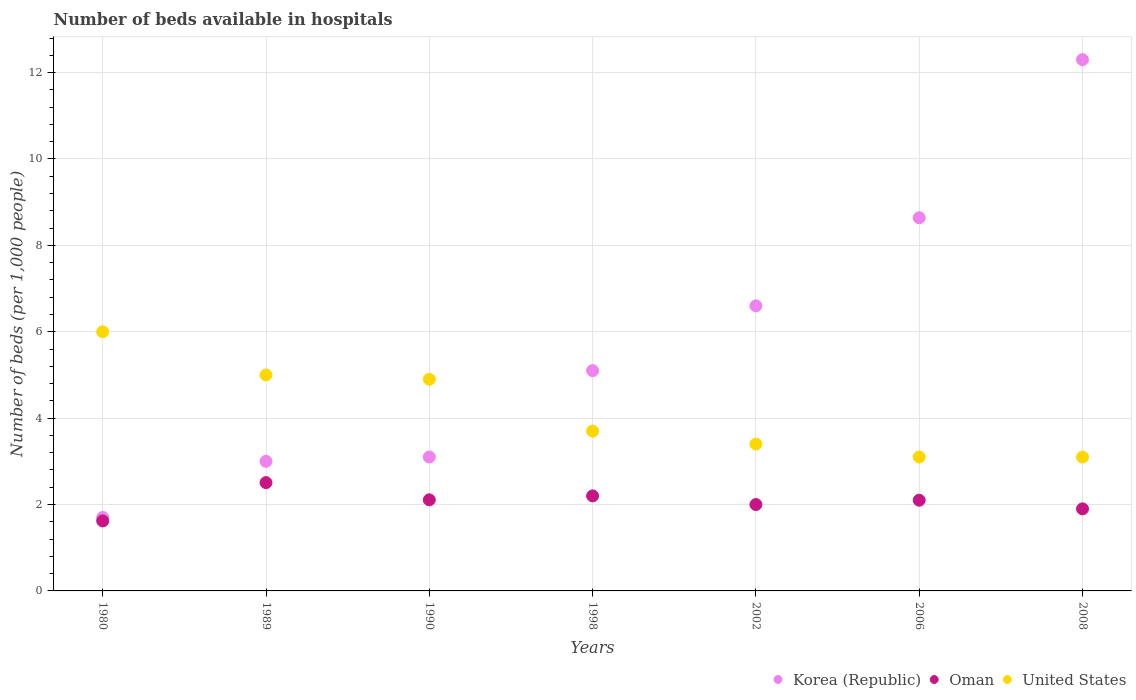How many different coloured dotlines are there?
Offer a very short reply. 3. Is the number of dotlines equal to the number of legend labels?
Offer a very short reply. Yes. What is the number of beds in the hospiatls of in Korea (Republic) in 1998?
Provide a short and direct response. 5.1. Across all years, what is the maximum number of beds in the hospiatls of in Oman?
Keep it short and to the point. 2.51. Across all years, what is the minimum number of beds in the hospiatls of in Korea (Republic)?
Offer a very short reply. 1.7. In which year was the number of beds in the hospiatls of in United States maximum?
Your answer should be compact. 1980. In which year was the number of beds in the hospiatls of in United States minimum?
Ensure brevity in your answer.  2006. What is the total number of beds in the hospiatls of in Korea (Republic) in the graph?
Provide a succinct answer. 40.44. What is the difference between the number of beds in the hospiatls of in United States in 1990 and that in 2008?
Your response must be concise. 1.8. What is the difference between the number of beds in the hospiatls of in Korea (Republic) in 2006 and the number of beds in the hospiatls of in Oman in 2008?
Offer a terse response. 6.74. What is the average number of beds in the hospiatls of in Oman per year?
Ensure brevity in your answer.  2.06. In the year 2008, what is the difference between the number of beds in the hospiatls of in Korea (Republic) and number of beds in the hospiatls of in United States?
Give a very brief answer. 9.2. What is the ratio of the number of beds in the hospiatls of in Oman in 1998 to that in 2008?
Offer a very short reply. 1.16. Is the number of beds in the hospiatls of in Korea (Republic) in 1989 less than that in 2006?
Ensure brevity in your answer.  Yes. What is the difference between the highest and the second highest number of beds in the hospiatls of in Korea (Republic)?
Your response must be concise. 3.66. In how many years, is the number of beds in the hospiatls of in Oman greater than the average number of beds in the hospiatls of in Oman taken over all years?
Your answer should be compact. 4. Is the sum of the number of beds in the hospiatls of in Oman in 1998 and 2006 greater than the maximum number of beds in the hospiatls of in Korea (Republic) across all years?
Make the answer very short. No. Is the number of beds in the hospiatls of in Korea (Republic) strictly greater than the number of beds in the hospiatls of in United States over the years?
Your response must be concise. No. Is the number of beds in the hospiatls of in Korea (Republic) strictly less than the number of beds in the hospiatls of in Oman over the years?
Your answer should be very brief. No. How many years are there in the graph?
Provide a succinct answer. 7. Are the values on the major ticks of Y-axis written in scientific E-notation?
Ensure brevity in your answer.  No. Does the graph contain grids?
Your answer should be very brief. Yes. Where does the legend appear in the graph?
Provide a succinct answer. Bottom right. How are the legend labels stacked?
Make the answer very short. Horizontal. What is the title of the graph?
Your response must be concise. Number of beds available in hospitals. Does "French Polynesia" appear as one of the legend labels in the graph?
Offer a very short reply. No. What is the label or title of the Y-axis?
Provide a succinct answer. Number of beds (per 1,0 people). What is the Number of beds (per 1,000 people) in Korea (Republic) in 1980?
Your answer should be very brief. 1.7. What is the Number of beds (per 1,000 people) of Oman in 1980?
Provide a succinct answer. 1.62. What is the Number of beds (per 1,000 people) of United States in 1980?
Offer a terse response. 6. What is the Number of beds (per 1,000 people) in Oman in 1989?
Keep it short and to the point. 2.51. What is the Number of beds (per 1,000 people) of Korea (Republic) in 1990?
Provide a succinct answer. 3.1. What is the Number of beds (per 1,000 people) in Oman in 1990?
Provide a succinct answer. 2.11. What is the Number of beds (per 1,000 people) of United States in 1990?
Offer a very short reply. 4.9. What is the Number of beds (per 1,000 people) of Korea (Republic) in 1998?
Your answer should be very brief. 5.1. What is the Number of beds (per 1,000 people) in Oman in 1998?
Keep it short and to the point. 2.2. What is the Number of beds (per 1,000 people) in United States in 1998?
Your answer should be very brief. 3.7. What is the Number of beds (per 1,000 people) in Korea (Republic) in 2002?
Your answer should be very brief. 6.6. What is the Number of beds (per 1,000 people) of Oman in 2002?
Keep it short and to the point. 2. What is the Number of beds (per 1,000 people) in United States in 2002?
Keep it short and to the point. 3.4. What is the Number of beds (per 1,000 people) of Korea (Republic) in 2006?
Offer a very short reply. 8.64. What is the Number of beds (per 1,000 people) of Oman in 2006?
Your response must be concise. 2.1. What is the Number of beds (per 1,000 people) of United States in 2006?
Offer a very short reply. 3.1. What is the Number of beds (per 1,000 people) of Korea (Republic) in 2008?
Provide a short and direct response. 12.3. What is the Number of beds (per 1,000 people) in United States in 2008?
Provide a short and direct response. 3.1. Across all years, what is the maximum Number of beds (per 1,000 people) of Oman?
Your response must be concise. 2.51. Across all years, what is the minimum Number of beds (per 1,000 people) in Korea (Republic)?
Your answer should be very brief. 1.7. Across all years, what is the minimum Number of beds (per 1,000 people) of Oman?
Give a very brief answer. 1.62. Across all years, what is the minimum Number of beds (per 1,000 people) of United States?
Your answer should be very brief. 3.1. What is the total Number of beds (per 1,000 people) in Korea (Republic) in the graph?
Ensure brevity in your answer.  40.44. What is the total Number of beds (per 1,000 people) of Oman in the graph?
Give a very brief answer. 14.44. What is the total Number of beds (per 1,000 people) in United States in the graph?
Provide a short and direct response. 29.2. What is the difference between the Number of beds (per 1,000 people) of Oman in 1980 and that in 1989?
Offer a terse response. -0.89. What is the difference between the Number of beds (per 1,000 people) of Korea (Republic) in 1980 and that in 1990?
Offer a terse response. -1.4. What is the difference between the Number of beds (per 1,000 people) in Oman in 1980 and that in 1990?
Your response must be concise. -0.49. What is the difference between the Number of beds (per 1,000 people) in United States in 1980 and that in 1990?
Give a very brief answer. 1.1. What is the difference between the Number of beds (per 1,000 people) in Oman in 1980 and that in 1998?
Make the answer very short. -0.58. What is the difference between the Number of beds (per 1,000 people) of Oman in 1980 and that in 2002?
Keep it short and to the point. -0.38. What is the difference between the Number of beds (per 1,000 people) in Korea (Republic) in 1980 and that in 2006?
Provide a succinct answer. -6.94. What is the difference between the Number of beds (per 1,000 people) of Oman in 1980 and that in 2006?
Offer a very short reply. -0.48. What is the difference between the Number of beds (per 1,000 people) in Korea (Republic) in 1980 and that in 2008?
Provide a short and direct response. -10.6. What is the difference between the Number of beds (per 1,000 people) in Oman in 1980 and that in 2008?
Make the answer very short. -0.28. What is the difference between the Number of beds (per 1,000 people) in United States in 1980 and that in 2008?
Provide a short and direct response. 2.9. What is the difference between the Number of beds (per 1,000 people) in Oman in 1989 and that in 1990?
Your response must be concise. 0.4. What is the difference between the Number of beds (per 1,000 people) of United States in 1989 and that in 1990?
Offer a terse response. 0.1. What is the difference between the Number of beds (per 1,000 people) of Oman in 1989 and that in 1998?
Provide a short and direct response. 0.31. What is the difference between the Number of beds (per 1,000 people) in United States in 1989 and that in 1998?
Provide a short and direct response. 1.3. What is the difference between the Number of beds (per 1,000 people) of Korea (Republic) in 1989 and that in 2002?
Ensure brevity in your answer.  -3.6. What is the difference between the Number of beds (per 1,000 people) in Oman in 1989 and that in 2002?
Your response must be concise. 0.51. What is the difference between the Number of beds (per 1,000 people) in Korea (Republic) in 1989 and that in 2006?
Your response must be concise. -5.64. What is the difference between the Number of beds (per 1,000 people) in Oman in 1989 and that in 2006?
Offer a very short reply. 0.41. What is the difference between the Number of beds (per 1,000 people) of United States in 1989 and that in 2006?
Keep it short and to the point. 1.9. What is the difference between the Number of beds (per 1,000 people) in Oman in 1989 and that in 2008?
Your response must be concise. 0.61. What is the difference between the Number of beds (per 1,000 people) of United States in 1989 and that in 2008?
Offer a terse response. 1.9. What is the difference between the Number of beds (per 1,000 people) in Korea (Republic) in 1990 and that in 1998?
Make the answer very short. -2. What is the difference between the Number of beds (per 1,000 people) of Oman in 1990 and that in 1998?
Make the answer very short. -0.09. What is the difference between the Number of beds (per 1,000 people) of Oman in 1990 and that in 2002?
Make the answer very short. 0.11. What is the difference between the Number of beds (per 1,000 people) in United States in 1990 and that in 2002?
Your response must be concise. 1.5. What is the difference between the Number of beds (per 1,000 people) of Korea (Republic) in 1990 and that in 2006?
Provide a short and direct response. -5.54. What is the difference between the Number of beds (per 1,000 people) in Oman in 1990 and that in 2006?
Make the answer very short. 0.01. What is the difference between the Number of beds (per 1,000 people) of Korea (Republic) in 1990 and that in 2008?
Offer a very short reply. -9.2. What is the difference between the Number of beds (per 1,000 people) of Oman in 1990 and that in 2008?
Provide a short and direct response. 0.21. What is the difference between the Number of beds (per 1,000 people) in United States in 1990 and that in 2008?
Give a very brief answer. 1.8. What is the difference between the Number of beds (per 1,000 people) in United States in 1998 and that in 2002?
Offer a very short reply. 0.3. What is the difference between the Number of beds (per 1,000 people) in Korea (Republic) in 1998 and that in 2006?
Give a very brief answer. -3.54. What is the difference between the Number of beds (per 1,000 people) in Oman in 1998 and that in 2006?
Ensure brevity in your answer.  0.1. What is the difference between the Number of beds (per 1,000 people) in Korea (Republic) in 1998 and that in 2008?
Keep it short and to the point. -7.2. What is the difference between the Number of beds (per 1,000 people) in United States in 1998 and that in 2008?
Offer a very short reply. 0.6. What is the difference between the Number of beds (per 1,000 people) of Korea (Republic) in 2002 and that in 2006?
Your response must be concise. -2.04. What is the difference between the Number of beds (per 1,000 people) in United States in 2002 and that in 2006?
Provide a succinct answer. 0.3. What is the difference between the Number of beds (per 1,000 people) in United States in 2002 and that in 2008?
Your response must be concise. 0.3. What is the difference between the Number of beds (per 1,000 people) of Korea (Republic) in 2006 and that in 2008?
Offer a very short reply. -3.66. What is the difference between the Number of beds (per 1,000 people) of Korea (Republic) in 1980 and the Number of beds (per 1,000 people) of Oman in 1989?
Keep it short and to the point. -0.81. What is the difference between the Number of beds (per 1,000 people) of Oman in 1980 and the Number of beds (per 1,000 people) of United States in 1989?
Make the answer very short. -3.38. What is the difference between the Number of beds (per 1,000 people) in Korea (Republic) in 1980 and the Number of beds (per 1,000 people) in Oman in 1990?
Make the answer very short. -0.41. What is the difference between the Number of beds (per 1,000 people) of Korea (Republic) in 1980 and the Number of beds (per 1,000 people) of United States in 1990?
Offer a very short reply. -3.2. What is the difference between the Number of beds (per 1,000 people) in Oman in 1980 and the Number of beds (per 1,000 people) in United States in 1990?
Provide a succinct answer. -3.28. What is the difference between the Number of beds (per 1,000 people) of Korea (Republic) in 1980 and the Number of beds (per 1,000 people) of United States in 1998?
Provide a short and direct response. -2. What is the difference between the Number of beds (per 1,000 people) in Oman in 1980 and the Number of beds (per 1,000 people) in United States in 1998?
Your answer should be very brief. -2.08. What is the difference between the Number of beds (per 1,000 people) of Korea (Republic) in 1980 and the Number of beds (per 1,000 people) of Oman in 2002?
Keep it short and to the point. -0.3. What is the difference between the Number of beds (per 1,000 people) of Korea (Republic) in 1980 and the Number of beds (per 1,000 people) of United States in 2002?
Your answer should be very brief. -1.7. What is the difference between the Number of beds (per 1,000 people) of Oman in 1980 and the Number of beds (per 1,000 people) of United States in 2002?
Give a very brief answer. -1.78. What is the difference between the Number of beds (per 1,000 people) in Oman in 1980 and the Number of beds (per 1,000 people) in United States in 2006?
Your answer should be very brief. -1.48. What is the difference between the Number of beds (per 1,000 people) of Oman in 1980 and the Number of beds (per 1,000 people) of United States in 2008?
Make the answer very short. -1.48. What is the difference between the Number of beds (per 1,000 people) of Korea (Republic) in 1989 and the Number of beds (per 1,000 people) of Oman in 1990?
Your answer should be very brief. 0.89. What is the difference between the Number of beds (per 1,000 people) of Korea (Republic) in 1989 and the Number of beds (per 1,000 people) of United States in 1990?
Offer a very short reply. -1.9. What is the difference between the Number of beds (per 1,000 people) in Oman in 1989 and the Number of beds (per 1,000 people) in United States in 1990?
Offer a very short reply. -2.39. What is the difference between the Number of beds (per 1,000 people) in Korea (Republic) in 1989 and the Number of beds (per 1,000 people) in Oman in 1998?
Ensure brevity in your answer.  0.8. What is the difference between the Number of beds (per 1,000 people) in Korea (Republic) in 1989 and the Number of beds (per 1,000 people) in United States in 1998?
Your answer should be very brief. -0.7. What is the difference between the Number of beds (per 1,000 people) of Oman in 1989 and the Number of beds (per 1,000 people) of United States in 1998?
Offer a terse response. -1.19. What is the difference between the Number of beds (per 1,000 people) in Korea (Republic) in 1989 and the Number of beds (per 1,000 people) in United States in 2002?
Offer a terse response. -0.4. What is the difference between the Number of beds (per 1,000 people) of Oman in 1989 and the Number of beds (per 1,000 people) of United States in 2002?
Keep it short and to the point. -0.89. What is the difference between the Number of beds (per 1,000 people) in Korea (Republic) in 1989 and the Number of beds (per 1,000 people) in Oman in 2006?
Make the answer very short. 0.9. What is the difference between the Number of beds (per 1,000 people) in Oman in 1989 and the Number of beds (per 1,000 people) in United States in 2006?
Provide a short and direct response. -0.59. What is the difference between the Number of beds (per 1,000 people) of Korea (Republic) in 1989 and the Number of beds (per 1,000 people) of Oman in 2008?
Ensure brevity in your answer.  1.1. What is the difference between the Number of beds (per 1,000 people) in Korea (Republic) in 1989 and the Number of beds (per 1,000 people) in United States in 2008?
Offer a very short reply. -0.1. What is the difference between the Number of beds (per 1,000 people) of Oman in 1989 and the Number of beds (per 1,000 people) of United States in 2008?
Provide a short and direct response. -0.59. What is the difference between the Number of beds (per 1,000 people) in Korea (Republic) in 1990 and the Number of beds (per 1,000 people) in Oman in 1998?
Your answer should be compact. 0.9. What is the difference between the Number of beds (per 1,000 people) of Korea (Republic) in 1990 and the Number of beds (per 1,000 people) of United States in 1998?
Ensure brevity in your answer.  -0.6. What is the difference between the Number of beds (per 1,000 people) of Oman in 1990 and the Number of beds (per 1,000 people) of United States in 1998?
Offer a terse response. -1.59. What is the difference between the Number of beds (per 1,000 people) of Oman in 1990 and the Number of beds (per 1,000 people) of United States in 2002?
Ensure brevity in your answer.  -1.29. What is the difference between the Number of beds (per 1,000 people) in Korea (Republic) in 1990 and the Number of beds (per 1,000 people) in Oman in 2006?
Make the answer very short. 1. What is the difference between the Number of beds (per 1,000 people) in Korea (Republic) in 1990 and the Number of beds (per 1,000 people) in United States in 2006?
Your response must be concise. -0. What is the difference between the Number of beds (per 1,000 people) in Oman in 1990 and the Number of beds (per 1,000 people) in United States in 2006?
Offer a very short reply. -0.99. What is the difference between the Number of beds (per 1,000 people) of Oman in 1990 and the Number of beds (per 1,000 people) of United States in 2008?
Keep it short and to the point. -0.99. What is the difference between the Number of beds (per 1,000 people) of Korea (Republic) in 1998 and the Number of beds (per 1,000 people) of Oman in 2006?
Offer a very short reply. 3. What is the difference between the Number of beds (per 1,000 people) in Korea (Republic) in 1998 and the Number of beds (per 1,000 people) in United States in 2006?
Keep it short and to the point. 2. What is the difference between the Number of beds (per 1,000 people) in Oman in 1998 and the Number of beds (per 1,000 people) in United States in 2008?
Keep it short and to the point. -0.9. What is the difference between the Number of beds (per 1,000 people) in Korea (Republic) in 2002 and the Number of beds (per 1,000 people) in Oman in 2006?
Give a very brief answer. 4.5. What is the difference between the Number of beds (per 1,000 people) of Korea (Republic) in 2002 and the Number of beds (per 1,000 people) of United States in 2006?
Your answer should be compact. 3.5. What is the difference between the Number of beds (per 1,000 people) in Korea (Republic) in 2002 and the Number of beds (per 1,000 people) in Oman in 2008?
Offer a very short reply. 4.7. What is the difference between the Number of beds (per 1,000 people) in Korea (Republic) in 2002 and the Number of beds (per 1,000 people) in United States in 2008?
Your response must be concise. 3.5. What is the difference between the Number of beds (per 1,000 people) of Oman in 2002 and the Number of beds (per 1,000 people) of United States in 2008?
Offer a very short reply. -1.1. What is the difference between the Number of beds (per 1,000 people) of Korea (Republic) in 2006 and the Number of beds (per 1,000 people) of Oman in 2008?
Provide a succinct answer. 6.74. What is the difference between the Number of beds (per 1,000 people) in Korea (Republic) in 2006 and the Number of beds (per 1,000 people) in United States in 2008?
Ensure brevity in your answer.  5.54. What is the difference between the Number of beds (per 1,000 people) in Oman in 2006 and the Number of beds (per 1,000 people) in United States in 2008?
Keep it short and to the point. -1. What is the average Number of beds (per 1,000 people) in Korea (Republic) per year?
Your response must be concise. 5.78. What is the average Number of beds (per 1,000 people) of Oman per year?
Give a very brief answer. 2.06. What is the average Number of beds (per 1,000 people) in United States per year?
Provide a short and direct response. 4.17. In the year 1980, what is the difference between the Number of beds (per 1,000 people) of Korea (Republic) and Number of beds (per 1,000 people) of Oman?
Offer a terse response. 0.08. In the year 1980, what is the difference between the Number of beds (per 1,000 people) in Oman and Number of beds (per 1,000 people) in United States?
Provide a succinct answer. -4.38. In the year 1989, what is the difference between the Number of beds (per 1,000 people) in Korea (Republic) and Number of beds (per 1,000 people) in Oman?
Provide a short and direct response. 0.49. In the year 1989, what is the difference between the Number of beds (per 1,000 people) of Korea (Republic) and Number of beds (per 1,000 people) of United States?
Provide a short and direct response. -2. In the year 1989, what is the difference between the Number of beds (per 1,000 people) in Oman and Number of beds (per 1,000 people) in United States?
Ensure brevity in your answer.  -2.49. In the year 1990, what is the difference between the Number of beds (per 1,000 people) in Korea (Republic) and Number of beds (per 1,000 people) in Oman?
Ensure brevity in your answer.  0.99. In the year 1990, what is the difference between the Number of beds (per 1,000 people) of Oman and Number of beds (per 1,000 people) of United States?
Provide a succinct answer. -2.79. In the year 1998, what is the difference between the Number of beds (per 1,000 people) of Korea (Republic) and Number of beds (per 1,000 people) of Oman?
Offer a very short reply. 2.9. In the year 1998, what is the difference between the Number of beds (per 1,000 people) in Korea (Republic) and Number of beds (per 1,000 people) in United States?
Offer a very short reply. 1.4. In the year 1998, what is the difference between the Number of beds (per 1,000 people) in Oman and Number of beds (per 1,000 people) in United States?
Make the answer very short. -1.5. In the year 2002, what is the difference between the Number of beds (per 1,000 people) in Korea (Republic) and Number of beds (per 1,000 people) in United States?
Your response must be concise. 3.2. In the year 2002, what is the difference between the Number of beds (per 1,000 people) of Oman and Number of beds (per 1,000 people) of United States?
Offer a terse response. -1.4. In the year 2006, what is the difference between the Number of beds (per 1,000 people) of Korea (Republic) and Number of beds (per 1,000 people) of Oman?
Make the answer very short. 6.54. In the year 2006, what is the difference between the Number of beds (per 1,000 people) in Korea (Republic) and Number of beds (per 1,000 people) in United States?
Make the answer very short. 5.54. In the year 2008, what is the difference between the Number of beds (per 1,000 people) of Oman and Number of beds (per 1,000 people) of United States?
Offer a very short reply. -1.2. What is the ratio of the Number of beds (per 1,000 people) in Korea (Republic) in 1980 to that in 1989?
Provide a short and direct response. 0.57. What is the ratio of the Number of beds (per 1,000 people) of Oman in 1980 to that in 1989?
Your response must be concise. 0.65. What is the ratio of the Number of beds (per 1,000 people) of United States in 1980 to that in 1989?
Your answer should be compact. 1.2. What is the ratio of the Number of beds (per 1,000 people) of Korea (Republic) in 1980 to that in 1990?
Keep it short and to the point. 0.55. What is the ratio of the Number of beds (per 1,000 people) of Oman in 1980 to that in 1990?
Your answer should be very brief. 0.77. What is the ratio of the Number of beds (per 1,000 people) in United States in 1980 to that in 1990?
Offer a very short reply. 1.22. What is the ratio of the Number of beds (per 1,000 people) in Korea (Republic) in 1980 to that in 1998?
Keep it short and to the point. 0.33. What is the ratio of the Number of beds (per 1,000 people) of Oman in 1980 to that in 1998?
Offer a very short reply. 0.74. What is the ratio of the Number of beds (per 1,000 people) of United States in 1980 to that in 1998?
Your response must be concise. 1.62. What is the ratio of the Number of beds (per 1,000 people) in Korea (Republic) in 1980 to that in 2002?
Offer a terse response. 0.26. What is the ratio of the Number of beds (per 1,000 people) of Oman in 1980 to that in 2002?
Ensure brevity in your answer.  0.81. What is the ratio of the Number of beds (per 1,000 people) of United States in 1980 to that in 2002?
Provide a succinct answer. 1.76. What is the ratio of the Number of beds (per 1,000 people) in Korea (Republic) in 1980 to that in 2006?
Offer a terse response. 0.2. What is the ratio of the Number of beds (per 1,000 people) in Oman in 1980 to that in 2006?
Give a very brief answer. 0.77. What is the ratio of the Number of beds (per 1,000 people) of United States in 1980 to that in 2006?
Provide a short and direct response. 1.94. What is the ratio of the Number of beds (per 1,000 people) of Korea (Republic) in 1980 to that in 2008?
Keep it short and to the point. 0.14. What is the ratio of the Number of beds (per 1,000 people) in Oman in 1980 to that in 2008?
Offer a terse response. 0.85. What is the ratio of the Number of beds (per 1,000 people) of United States in 1980 to that in 2008?
Keep it short and to the point. 1.94. What is the ratio of the Number of beds (per 1,000 people) in Korea (Republic) in 1989 to that in 1990?
Your answer should be compact. 0.97. What is the ratio of the Number of beds (per 1,000 people) in Oman in 1989 to that in 1990?
Provide a succinct answer. 1.19. What is the ratio of the Number of beds (per 1,000 people) in United States in 1989 to that in 1990?
Your answer should be very brief. 1.02. What is the ratio of the Number of beds (per 1,000 people) of Korea (Republic) in 1989 to that in 1998?
Keep it short and to the point. 0.59. What is the ratio of the Number of beds (per 1,000 people) of Oman in 1989 to that in 1998?
Your answer should be compact. 1.14. What is the ratio of the Number of beds (per 1,000 people) in United States in 1989 to that in 1998?
Your answer should be very brief. 1.35. What is the ratio of the Number of beds (per 1,000 people) in Korea (Republic) in 1989 to that in 2002?
Make the answer very short. 0.45. What is the ratio of the Number of beds (per 1,000 people) in Oman in 1989 to that in 2002?
Offer a very short reply. 1.25. What is the ratio of the Number of beds (per 1,000 people) of United States in 1989 to that in 2002?
Your response must be concise. 1.47. What is the ratio of the Number of beds (per 1,000 people) of Korea (Republic) in 1989 to that in 2006?
Ensure brevity in your answer.  0.35. What is the ratio of the Number of beds (per 1,000 people) in Oman in 1989 to that in 2006?
Offer a very short reply. 1.19. What is the ratio of the Number of beds (per 1,000 people) of United States in 1989 to that in 2006?
Ensure brevity in your answer.  1.61. What is the ratio of the Number of beds (per 1,000 people) in Korea (Republic) in 1989 to that in 2008?
Make the answer very short. 0.24. What is the ratio of the Number of beds (per 1,000 people) in Oman in 1989 to that in 2008?
Offer a very short reply. 1.32. What is the ratio of the Number of beds (per 1,000 people) of United States in 1989 to that in 2008?
Give a very brief answer. 1.61. What is the ratio of the Number of beds (per 1,000 people) in Korea (Republic) in 1990 to that in 1998?
Provide a succinct answer. 0.61. What is the ratio of the Number of beds (per 1,000 people) of Oman in 1990 to that in 1998?
Your response must be concise. 0.96. What is the ratio of the Number of beds (per 1,000 people) in United States in 1990 to that in 1998?
Keep it short and to the point. 1.32. What is the ratio of the Number of beds (per 1,000 people) in Korea (Republic) in 1990 to that in 2002?
Your response must be concise. 0.47. What is the ratio of the Number of beds (per 1,000 people) of Oman in 1990 to that in 2002?
Make the answer very short. 1.05. What is the ratio of the Number of beds (per 1,000 people) in United States in 1990 to that in 2002?
Your answer should be compact. 1.44. What is the ratio of the Number of beds (per 1,000 people) in Korea (Republic) in 1990 to that in 2006?
Give a very brief answer. 0.36. What is the ratio of the Number of beds (per 1,000 people) in United States in 1990 to that in 2006?
Give a very brief answer. 1.58. What is the ratio of the Number of beds (per 1,000 people) of Korea (Republic) in 1990 to that in 2008?
Give a very brief answer. 0.25. What is the ratio of the Number of beds (per 1,000 people) in Oman in 1990 to that in 2008?
Give a very brief answer. 1.11. What is the ratio of the Number of beds (per 1,000 people) in United States in 1990 to that in 2008?
Provide a succinct answer. 1.58. What is the ratio of the Number of beds (per 1,000 people) in Korea (Republic) in 1998 to that in 2002?
Make the answer very short. 0.77. What is the ratio of the Number of beds (per 1,000 people) in United States in 1998 to that in 2002?
Provide a succinct answer. 1.09. What is the ratio of the Number of beds (per 1,000 people) of Korea (Republic) in 1998 to that in 2006?
Your response must be concise. 0.59. What is the ratio of the Number of beds (per 1,000 people) in Oman in 1998 to that in 2006?
Give a very brief answer. 1.05. What is the ratio of the Number of beds (per 1,000 people) of United States in 1998 to that in 2006?
Provide a short and direct response. 1.19. What is the ratio of the Number of beds (per 1,000 people) of Korea (Republic) in 1998 to that in 2008?
Give a very brief answer. 0.41. What is the ratio of the Number of beds (per 1,000 people) in Oman in 1998 to that in 2008?
Your answer should be compact. 1.16. What is the ratio of the Number of beds (per 1,000 people) in United States in 1998 to that in 2008?
Your answer should be compact. 1.19. What is the ratio of the Number of beds (per 1,000 people) in Korea (Republic) in 2002 to that in 2006?
Give a very brief answer. 0.76. What is the ratio of the Number of beds (per 1,000 people) in Oman in 2002 to that in 2006?
Make the answer very short. 0.95. What is the ratio of the Number of beds (per 1,000 people) in United States in 2002 to that in 2006?
Offer a terse response. 1.1. What is the ratio of the Number of beds (per 1,000 people) of Korea (Republic) in 2002 to that in 2008?
Keep it short and to the point. 0.54. What is the ratio of the Number of beds (per 1,000 people) of Oman in 2002 to that in 2008?
Make the answer very short. 1.05. What is the ratio of the Number of beds (per 1,000 people) of United States in 2002 to that in 2008?
Provide a succinct answer. 1.1. What is the ratio of the Number of beds (per 1,000 people) in Korea (Republic) in 2006 to that in 2008?
Make the answer very short. 0.7. What is the ratio of the Number of beds (per 1,000 people) of Oman in 2006 to that in 2008?
Provide a succinct answer. 1.11. What is the ratio of the Number of beds (per 1,000 people) of United States in 2006 to that in 2008?
Offer a very short reply. 1. What is the difference between the highest and the second highest Number of beds (per 1,000 people) of Korea (Republic)?
Your answer should be compact. 3.66. What is the difference between the highest and the second highest Number of beds (per 1,000 people) of Oman?
Your answer should be compact. 0.31. What is the difference between the highest and the second highest Number of beds (per 1,000 people) in United States?
Ensure brevity in your answer.  1. What is the difference between the highest and the lowest Number of beds (per 1,000 people) in Korea (Republic)?
Provide a short and direct response. 10.6. What is the difference between the highest and the lowest Number of beds (per 1,000 people) of Oman?
Your answer should be very brief. 0.89. 